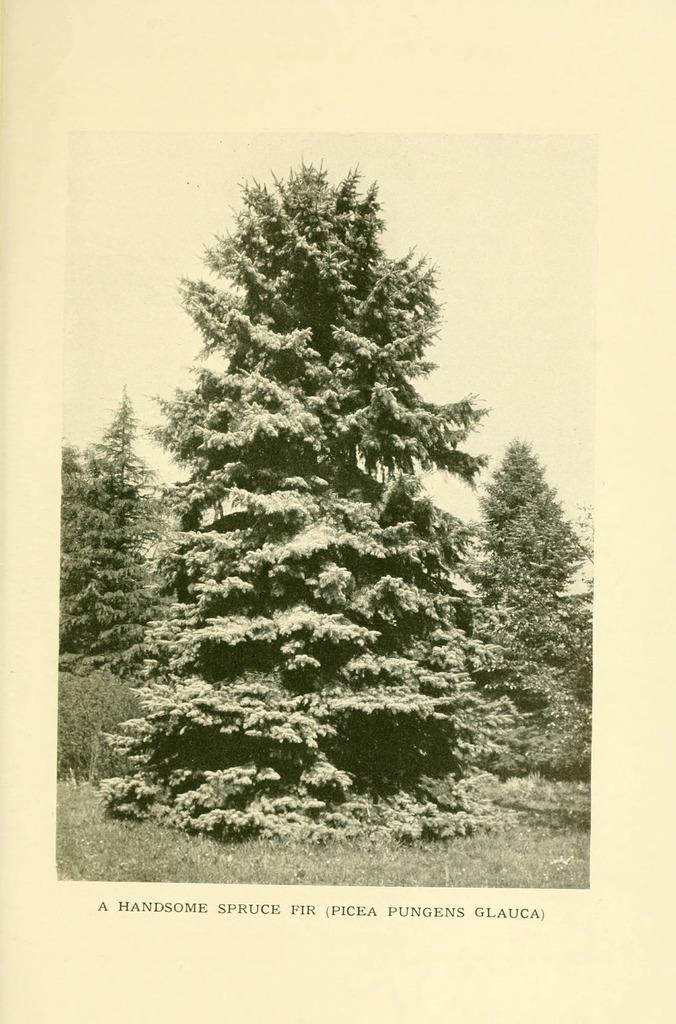What type of vegetation can be seen in the image? There are trees in the image. What else can be seen on the ground in the image? There is grass in the image. Is there any text present in the image? Yes, there is some text written at the bottom of the image. Can you tell me how many buildings are visible in the image? There are no buildings present in the image; it features trees and grass. What type of flight is taking place in the image? There is no flight present in the image; it only shows trees, grass, and text. 